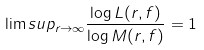Convert formula to latex. <formula><loc_0><loc_0><loc_500><loc_500>\lim s u p _ { r \to \infty } \frac { \log L ( r , f ) } { \log M ( r , f ) } = 1</formula> 